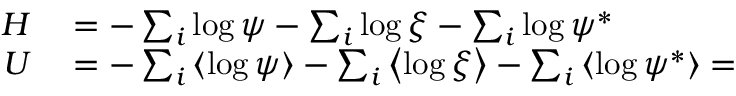Convert formula to latex. <formula><loc_0><loc_0><loc_500><loc_500>\begin{array} { r l } { H } & = - \sum _ { i } \log \psi - \sum _ { i } \log \xi - \sum _ { i } \log \psi ^ { * } } \\ { U } & = - \sum _ { i } \left \langle \log \psi \right \rangle - \sum _ { i } \left \langle \log \xi \right \rangle - \sum _ { i } \left \langle \log \psi ^ { * } \right \rangle = } \end{array}</formula> 